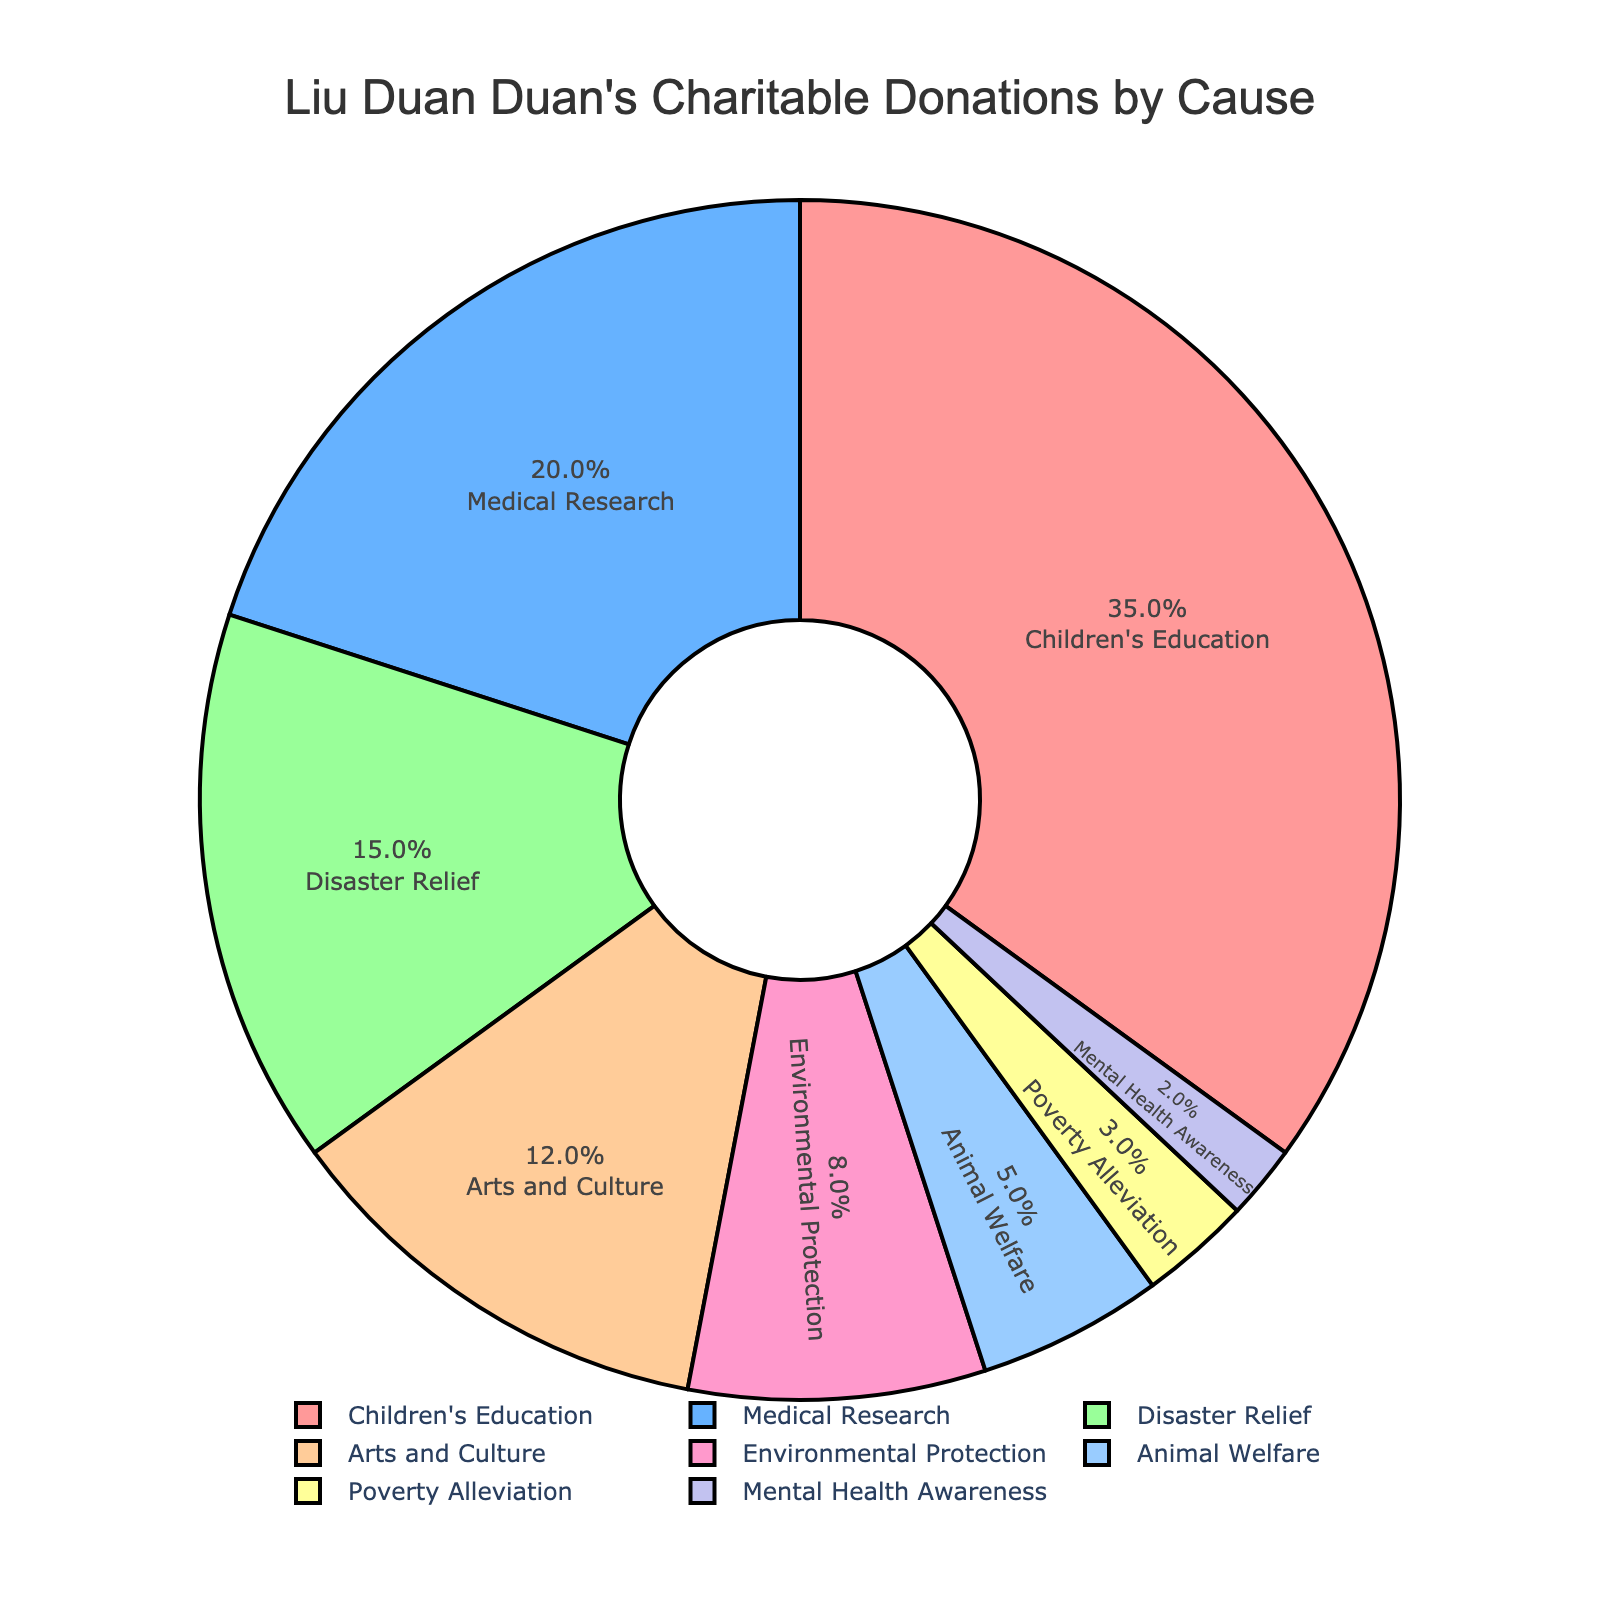Which cause receives the most donations? The largest segment on the pie chart represents the cause receiving the most donations. The segment labeled "Children's Education" occupies the largest portion of the chart.
Answer: Children's Education Which cause receives the least donations? The smallest segment on the pie chart represents the cause receiving the least donations. The segment labeled "Mental Health Awareness" occupies the smallest portion of the chart.
Answer: Mental Health Awareness What is the combined percentage of donations going to Arts and Culture and Environmental Protection? Add the percentages of the "Arts and Culture" and "Environmental Protection" segments: 12% + 8%.
Answer: 20% Which causes together account for half (50%) of Liu Duan Duan's charitable donations? Identify causes whose combined percentages add up to 50%. Adding "Children's Education" (35%) and "Medical Research" (20%) gives 55%, which exceeds 50%. Looking at other combinations, "Children's Education" (35%) + "Disaster Relief" (15%) equals exactly 50%.
Answer: Children's Education and Disaster Relief By how much does the percentage of donations for Medical Research exceed that for Animal Welfare? Subtract the percentage for Animal Welfare from the percentage for Medical Research: 20% - 5%.
Answer: 15% Which causes receive more than 10% of the donations each? Identify the segments with percentages greater than 10%. These are "Children's Education" (35%), "Medical Research" (20%), "Disaster Relief" (15%), and "Arts and Culture" (12%).
Answer: Children's Education, Medical Research, Disaster Relief, Arts and Culture If Liu Duan Duan decided to split his donations equally between Disaster Relief, Environmental Protection, and Animal Welfare, what percentage would each cause receive? Combine the percentages for Disaster Relief, Environmental Protection, and Animal Welfare, then divide by 3: (15% + 8% + 5%) / 3.
Answer: 9.33% How does the donation percentage for Poverty Alleviation compare to Mental Health Awareness? Compare their respective percentages: Poverty Alleviation (3%) is greater than Mental Health Awareness (2%).
Answer: Greater If Liu Duan Duan increased his donations to Mental Health Awareness by 4%, what would be its new percentage? Add 4% to the current percentage: 2% + 4%.
Answer: 6% 